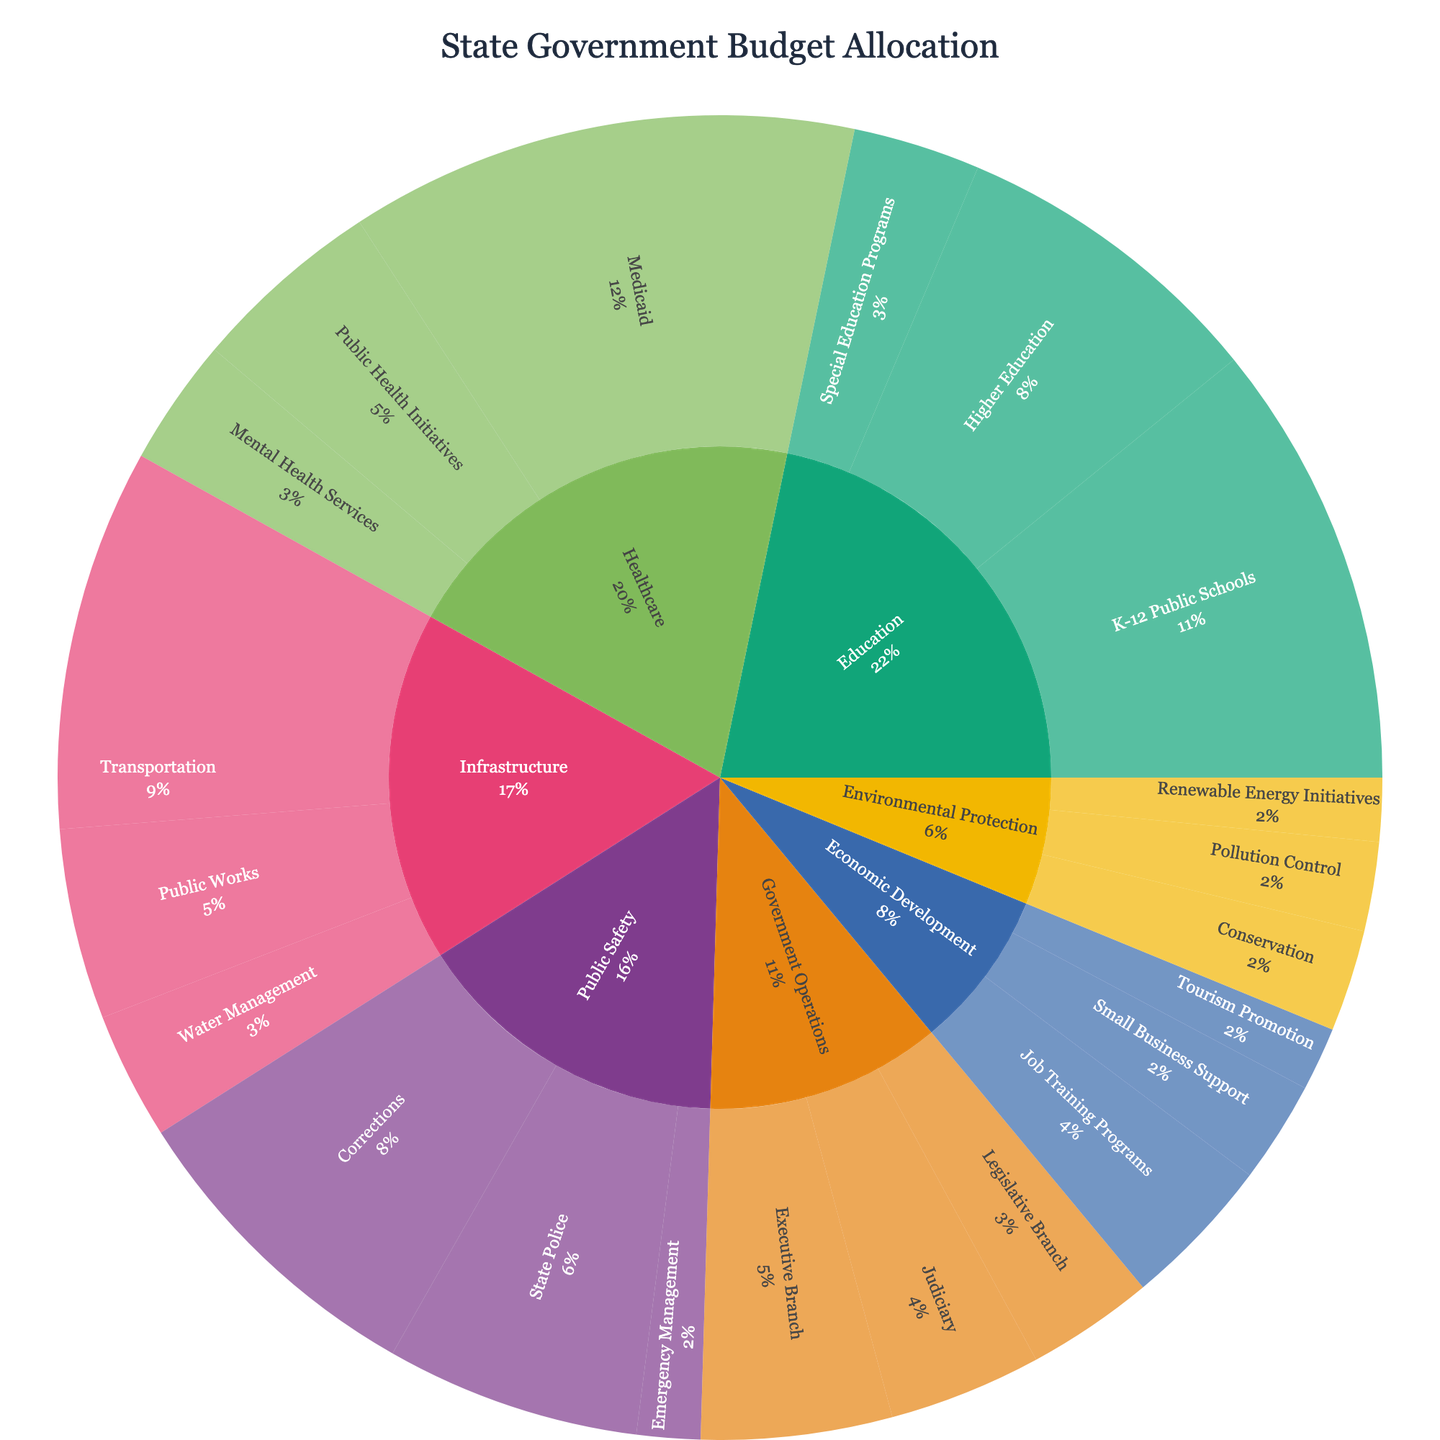How much of the total budget is allocated to the Education category? The Education category has three sub-categories: "K-12 Public Schools" with $35,000,000, "Higher Education" with $25,000,000, and "Special Education Programs" with $10,000,000. Summing these amounts gives the total allocation for Education.
Answer: $70,000,000 Which sub-category within the Public Safety category receives the most funding? The sub-categories within Public Safety are "State Police" with $20,000,000, "Corrections" with $25,000,000, and "Emergency Management" with $5,000,000. The highest value is for Corrections.
Answer: Corrections What percentage of the total budget is allocated to Healthcare? Adding the values for Healthcare: "Medicaid" with $40,000,000, "Public Health Initiatives" with $15,000,000, and "Mental Health Services" with $10,000,000 gives a total of $65,000,000. Summing up all category values gives a total budget of $295,000,000. The percentage is calculated as ($65,000,000 / $295,000,000) * 100.
Answer: 22.0% Does the Infrastructure category receive more or less funding than the Economic Development category? First sum the values for Infrastructure: "Transportation" with $30,000,000, "Public Works" with $15,000,000, and "Water Management" with $10,000,000, totaling $55,000,000. Then sum the values for Economic Development: "Job Training Programs" with $12,000,000, "Small Business Support" with $8,000,000, and "Tourism Promotion" with $5,000,000, totaling $25,000,000. Compare the two totals.
Answer: More Which category has the smallest portion of the total budget allocation? The categories are Education, Healthcare, Public Safety, Infrastructure, Environmental Protection, Economic Development, and Government Operations. By summing their respective sub-category values and comparing the totals, Environmental Protection has the smallest with $20,000,000.
Answer: Environmental Protection What is the combined budget for all sub-categories under Government Operations? The sub-categories under Government Operations are "Legislative Branch" with $10,000,000, "Executive Branch" with $15,000,000, and "Judiciary" with $12,000,000. Summing these gives the total.
Answer: $37,000,000 How does the budget for Infrastructure compare to the budget for Education? The total budget for Infrastructure is $55,000,000, and for Education, it is $70,000,000. Comparing the two, Education receives more funding.
Answer: Education receives more Identify the largest single sub-category allocation across all categories. Reviewing all sub-category values, "Medicaid" under Healthcare with $40,000,000 is the largest single allocation.
Answer: Medicaid What portion of the Healthcare budget is allocated to Mental Health Services? The total Healthcare budget is $65,000,000. The Mental Health Services allocation is $10,000,000. The portion is calculated as ($10,000,000 / $65,000,000) * 100.
Answer: 15.4% Is the total allocation for Public Safety greater than the total for Environmental Protection and Economic Development combined? The total allocation for Public Safety is $50,000,000. The combined total for Environmental Protection ($20,000,000) and Economic Development ($25,000,000) is $45,000,000. Comparing the totals, Public Safety has a higher allocation.
Answer: Yes 